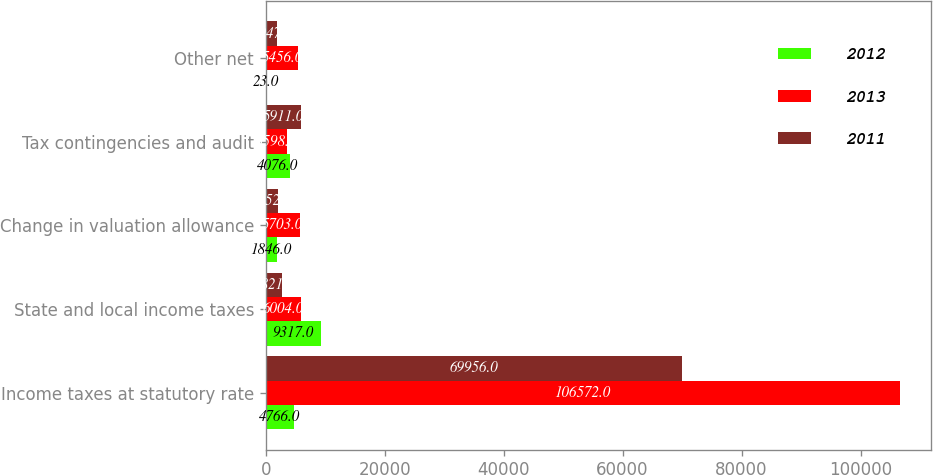Convert chart. <chart><loc_0><loc_0><loc_500><loc_500><stacked_bar_chart><ecel><fcel>Income taxes at statutory rate<fcel>State and local income taxes<fcel>Change in valuation allowance<fcel>Tax contingencies and audit<fcel>Other net<nl><fcel>2012<fcel>4766<fcel>9317<fcel>1846<fcel>4076<fcel>23<nl><fcel>2013<fcel>106572<fcel>6004<fcel>5703<fcel>3598<fcel>5456<nl><fcel>2011<fcel>69956<fcel>2821<fcel>2052<fcel>5911<fcel>1947<nl></chart> 